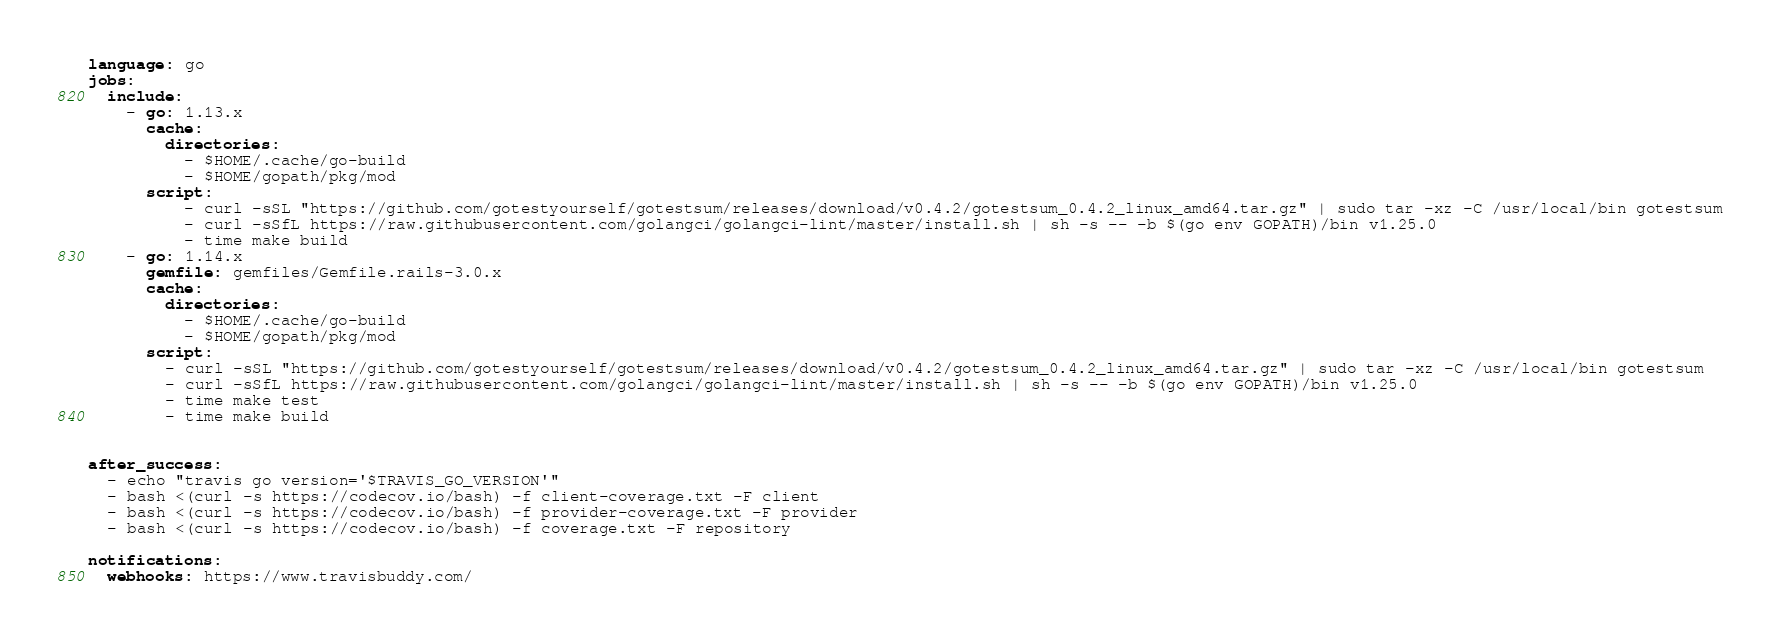Convert code to text. <code><loc_0><loc_0><loc_500><loc_500><_YAML_>language: go
jobs:
  include:
    - go: 1.13.x
      cache:
        directories:
          - $HOME/.cache/go-build
          - $HOME/gopath/pkg/mod
      script:
          - curl -sSL "https://github.com/gotestyourself/gotestsum/releases/download/v0.4.2/gotestsum_0.4.2_linux_amd64.tar.gz" | sudo tar -xz -C /usr/local/bin gotestsum
          - curl -sSfL https://raw.githubusercontent.com/golangci/golangci-lint/master/install.sh | sh -s -- -b $(go env GOPATH)/bin v1.25.0
          - time make build
    - go: 1.14.x
      gemfile: gemfiles/Gemfile.rails-3.0.x
      cache:
        directories:
          - $HOME/.cache/go-build
          - $HOME/gopath/pkg/mod
      script:
        - curl -sSL "https://github.com/gotestyourself/gotestsum/releases/download/v0.4.2/gotestsum_0.4.2_linux_amd64.tar.gz" | sudo tar -xz -C /usr/local/bin gotestsum
        - curl -sSfL https://raw.githubusercontent.com/golangci/golangci-lint/master/install.sh | sh -s -- -b $(go env GOPATH)/bin v1.25.0
        - time make test
        - time make build


after_success:
  - echo "travis go version='$TRAVIS_GO_VERSION'"
  - bash <(curl -s https://codecov.io/bash) -f client-coverage.txt -F client
  - bash <(curl -s https://codecov.io/bash) -f provider-coverage.txt -F provider
  - bash <(curl -s https://codecov.io/bash) -f coverage.txt -F repository

notifications:
  webhooks: https://www.travisbuddy.com/
</code> 